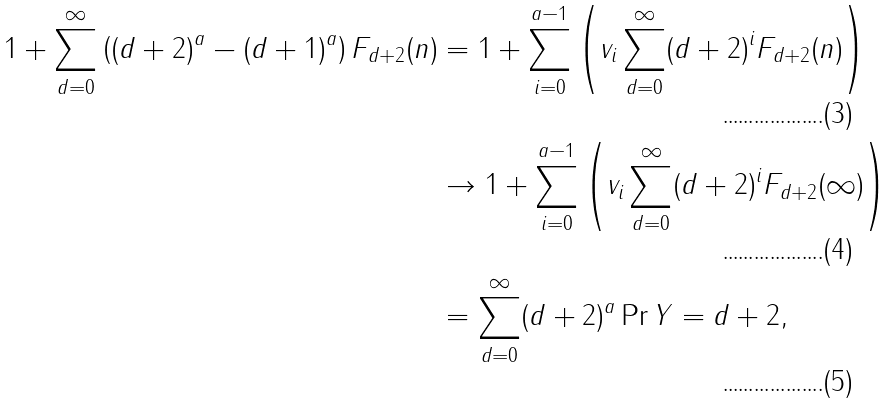Convert formula to latex. <formula><loc_0><loc_0><loc_500><loc_500>1 + \sum _ { d = 0 } ^ { \infty } \left ( ( d + 2 ) ^ { a } - ( d + 1 ) ^ { a } \right ) F _ { d + 2 } ( n ) & = 1 + \sum _ { i = 0 } ^ { a - 1 } \left ( v _ { i } \sum _ { d = 0 } ^ { \infty } ( d + 2 ) ^ { i } F _ { d + 2 } ( n ) \right ) \\ & \rightarrow 1 + \sum _ { i = 0 } ^ { a - 1 } \left ( v _ { i } \sum _ { d = 0 } ^ { \infty } ( d + 2 ) ^ { i } F _ { d + 2 } ( \infty ) \right ) \\ & = \sum _ { d = 0 } ^ { \infty } ( d + 2 ) ^ { a } \Pr { Y = d + 2 } ,</formula> 